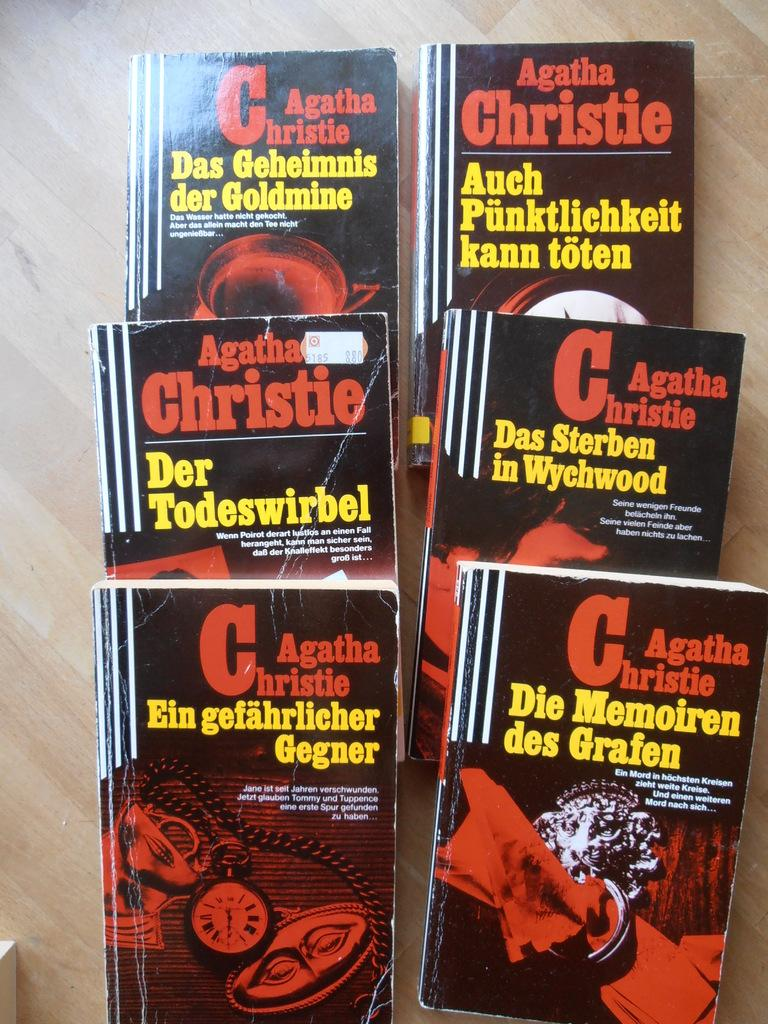Provide a one-sentence caption for the provided image. A collection of Agatha Christie novels are lying on a table. 